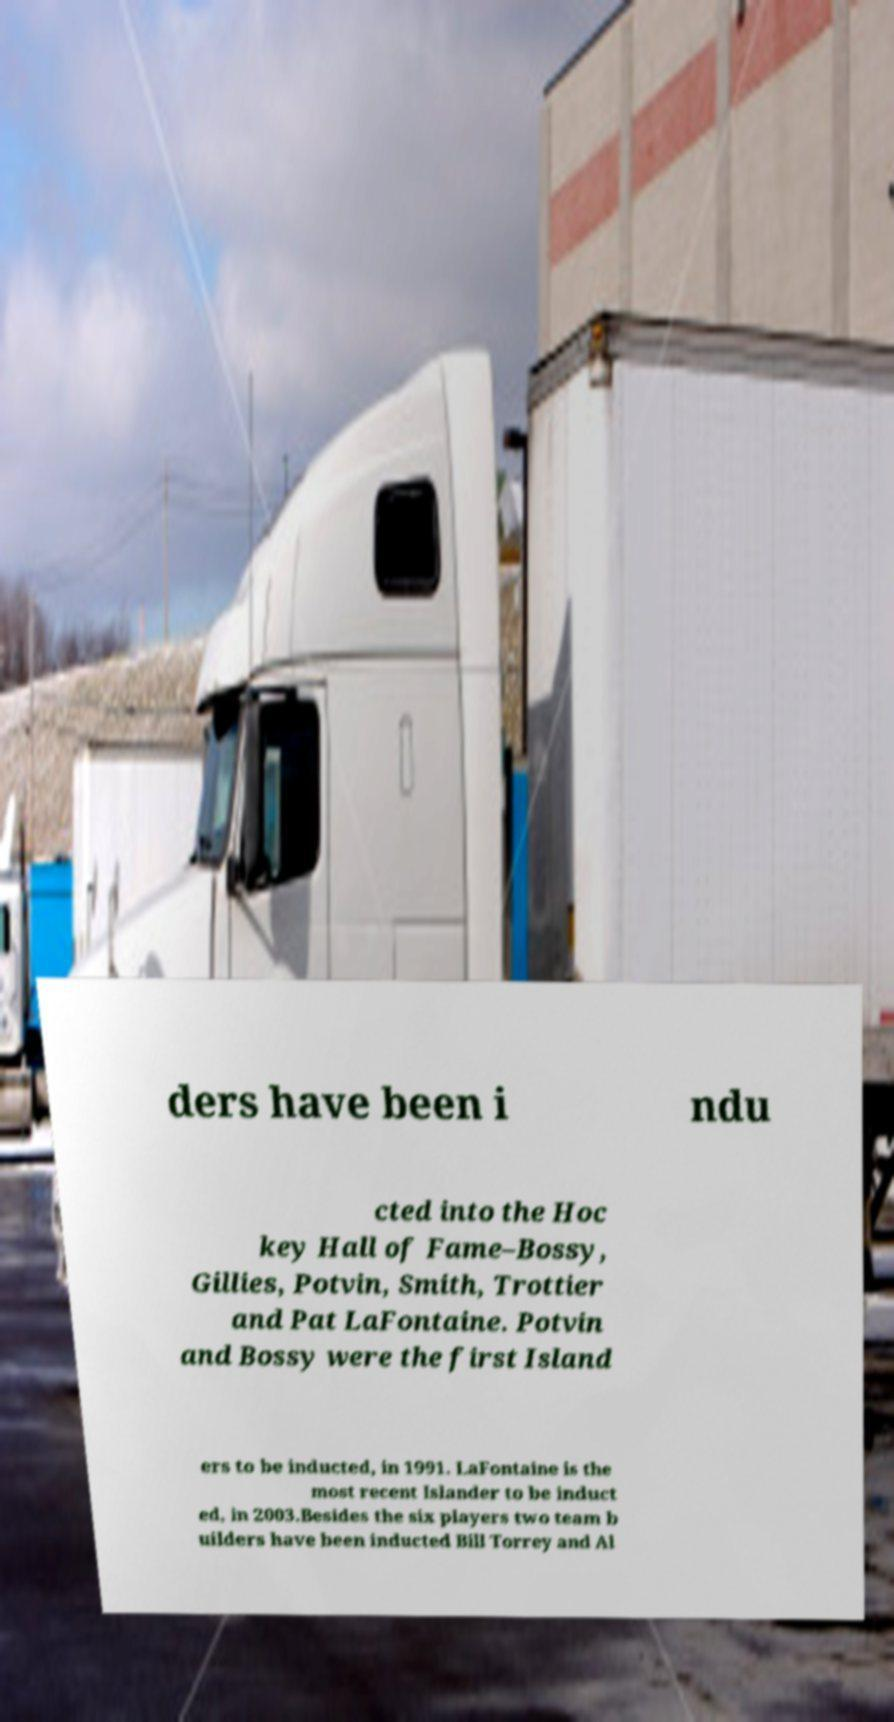For documentation purposes, I need the text within this image transcribed. Could you provide that? ders have been i ndu cted into the Hoc key Hall of Fame–Bossy, Gillies, Potvin, Smith, Trottier and Pat LaFontaine. Potvin and Bossy were the first Island ers to be inducted, in 1991. LaFontaine is the most recent Islander to be induct ed, in 2003.Besides the six players two team b uilders have been inducted Bill Torrey and Al 